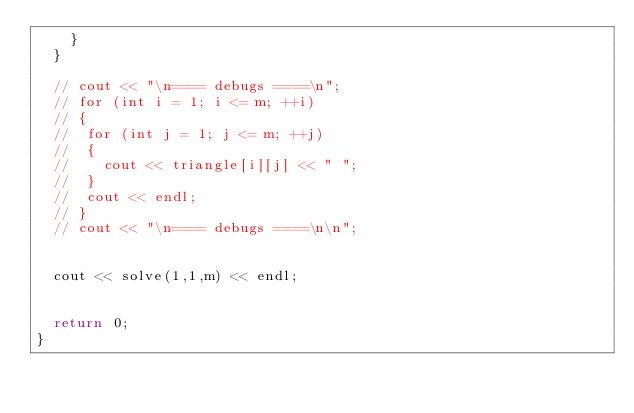<code> <loc_0><loc_0><loc_500><loc_500><_C++_>		}
	}

	// cout << "\n==== debugs ====\n";
	// for (int i = 1; i <= m; ++i)
	// {
	// 	for (int j = 1; j <= m; ++j)
	// 	{
	// 		cout << triangle[i][j] << " ";
	// 	}
	// 	cout << endl;
	// }
	// cout << "\n==== debugs ====\n\n";


	cout << solve(1,1,m) << endl;


	return 0;
}</code> 